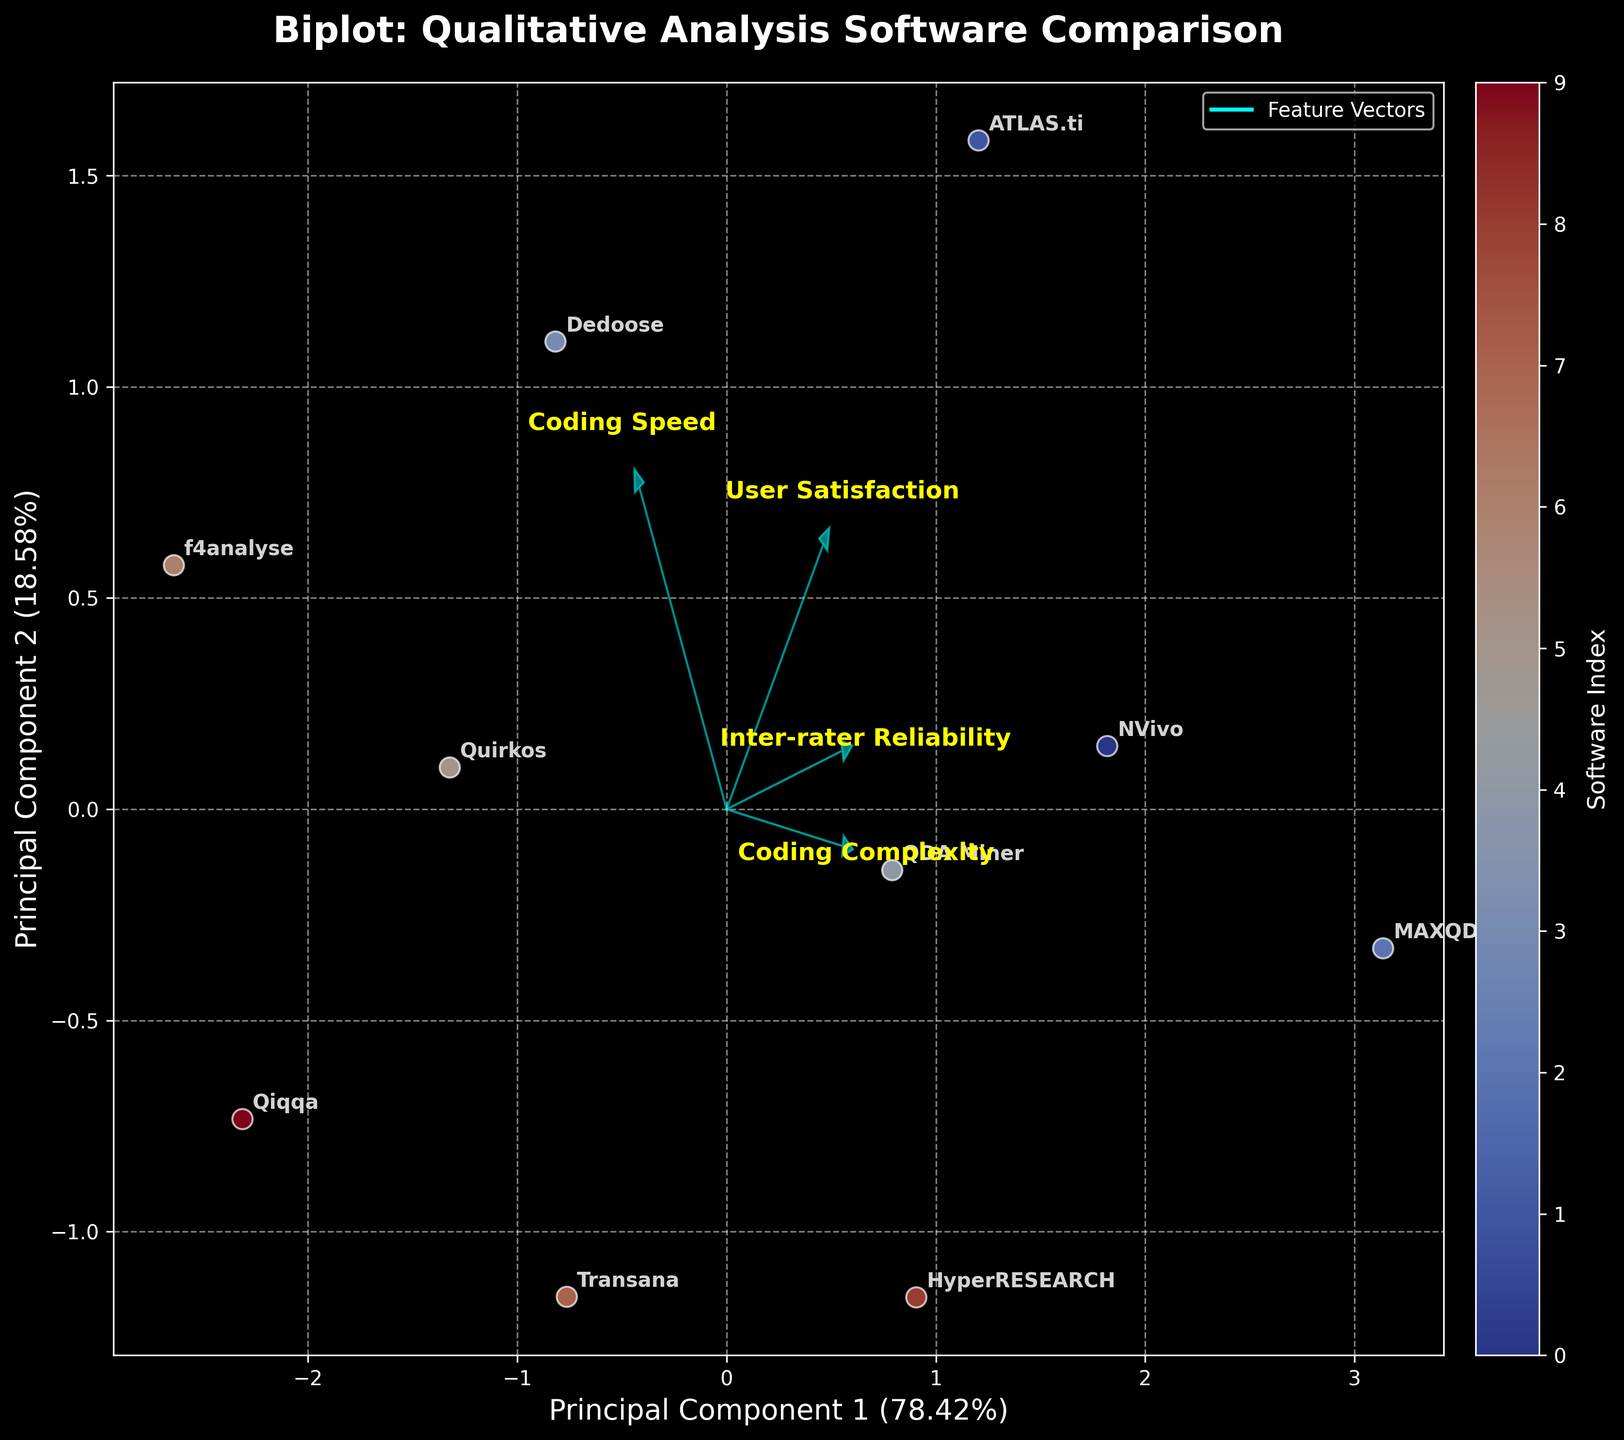Which software has the highest Inter-rater Reliability score? The biplot shows the position of each software along the Principal Component 1 and Principal Component 2 axes. By examining where the software points are positioned, you can identify the one with the highest Inter-rater Reliability score. MAXQDA has the highest Inter-rater Reliability score among all the software.
Answer: MAXQDA Which software appears to be the most complex in terms of coding? In the biplot, coding complexity is represented by one of the feature vectors. By examining the direction and length of the vector corresponding to coding complexity, we can see the position of each software relative to this vector. MAXQDA is positioned nearest to the coding complexity vector, indicating it is the most complex in terms of coding.
Answer: MAXQDA How do NVivo and Dedoose compare in terms of user satisfaction? By examining the position of NVivo and Dedoose in relation to the user satisfaction vector, you can determine their relative user satisfaction scores. NVivo has higher user satisfaction compared to Dedoose, as it is positioned closer to the user satisfaction vector.
Answer: NVivo has higher user satisfaction Is there a software that combines high Inter-rater Reliability and low coding complexity? To answer this, we need to look for a software that is positioned close to the Inter-rater Reliability vector but far from the coding complexity vector. NVivo and ATLAS.ti both show high Inter-rater Reliability, but among them, ATLAS.ti shows relatively low coding complexity.
Answer: ATLAS.ti Which software has the lowest Inter-rater Reliability score? By looking at the biplot and identifying the software positioned furthest from the Inter-rater Reliability vector, we can find the one with the lowest score. Qiqqa has the lowest Inter-rater Reliability score.
Answer: Qiqqa What does the position of HyperRESEARCH indicate in terms of coding speed and complexity? HyperRESEARCH is situated towards the middle of the biplot. By analyzing its position relative to the coding speed and complexity vectors, it shows moderate values for both attributes. This indicates that HyperRESEARCH has average coding speed and complexity.
Answer: Moderate coding speed and complexity Which software shows a contradiction in terms of high coding speed but low user satisfaction? Finding the software positioned close to the coding speed vector but far from the user satisfaction vector can answer this question. Dedoose demonstrates high coding speed but has relatively low user satisfaction.
Answer: Dedoose Which software has the closest balance among all the attributes considered? By identifying the software positioned near the center of the biplot, you can determine the one with a balanced performance across all attributes. QDA Miner is positioned near the center, indicating a balance among all attributes.
Answer: QDA Miner 